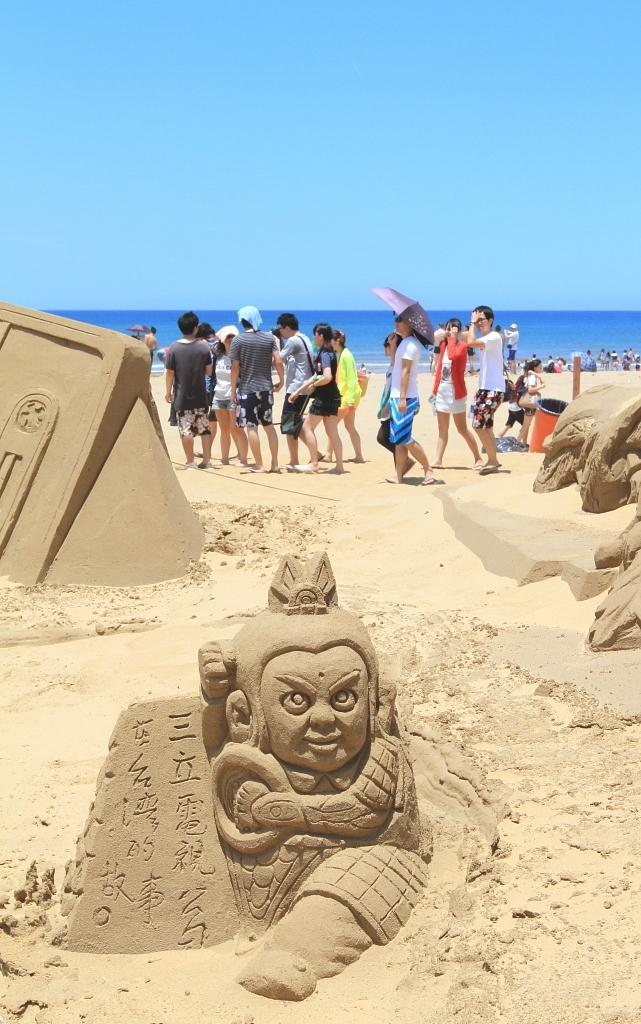What type of art can be seen in the image? There are sand arts in the image. What are the people in the image doing? People are sanding in the image. Can you describe the person holding an umbrella? Yes, a person is holding an umbrella in the image. What can be seen in the background of the image? There is water visible in the background of the image. What type of card is being used to comb the person's hair in the image? There is no card or combing activity present in the image. 